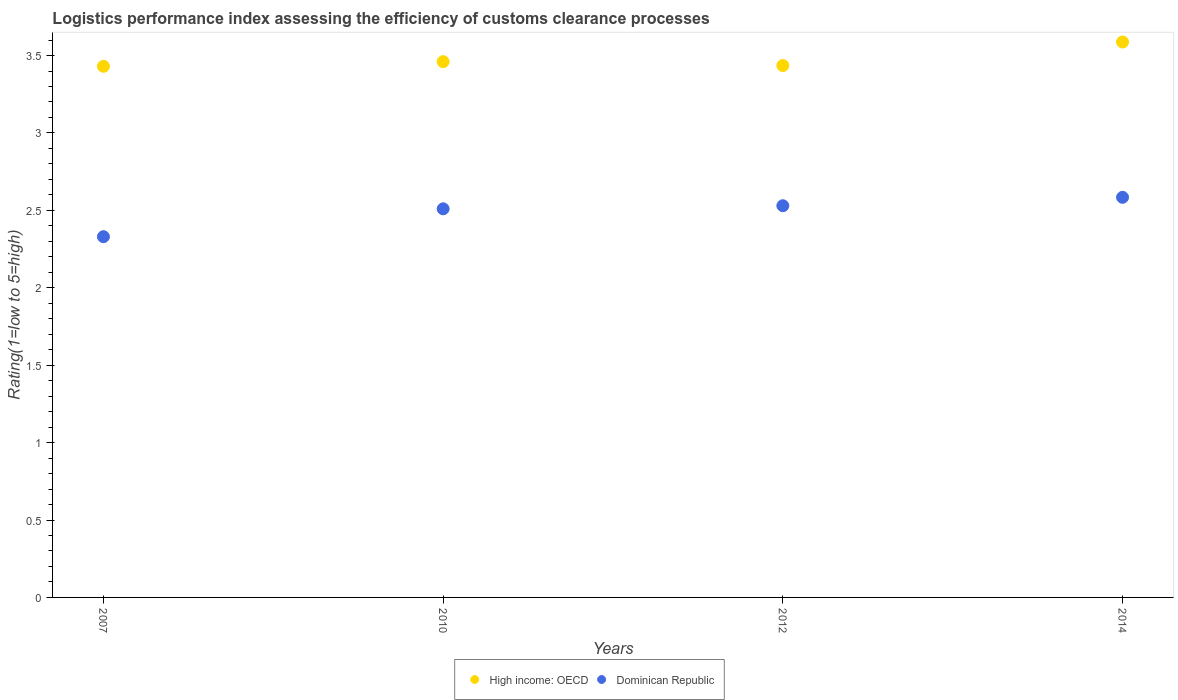How many different coloured dotlines are there?
Ensure brevity in your answer.  2. What is the Logistic performance index in High income: OECD in 2010?
Your answer should be compact. 3.46. Across all years, what is the maximum Logistic performance index in Dominican Republic?
Keep it short and to the point. 2.58. Across all years, what is the minimum Logistic performance index in Dominican Republic?
Ensure brevity in your answer.  2.33. In which year was the Logistic performance index in Dominican Republic maximum?
Offer a very short reply. 2014. In which year was the Logistic performance index in Dominican Republic minimum?
Make the answer very short. 2007. What is the total Logistic performance index in Dominican Republic in the graph?
Give a very brief answer. 9.95. What is the difference between the Logistic performance index in Dominican Republic in 2010 and that in 2012?
Keep it short and to the point. -0.02. What is the difference between the Logistic performance index in Dominican Republic in 2014 and the Logistic performance index in High income: OECD in 2007?
Give a very brief answer. -0.85. What is the average Logistic performance index in Dominican Republic per year?
Keep it short and to the point. 2.49. In the year 2007, what is the difference between the Logistic performance index in High income: OECD and Logistic performance index in Dominican Republic?
Ensure brevity in your answer.  1.1. What is the ratio of the Logistic performance index in High income: OECD in 2010 to that in 2012?
Keep it short and to the point. 1.01. Is the Logistic performance index in Dominican Republic in 2007 less than that in 2014?
Ensure brevity in your answer.  Yes. Is the difference between the Logistic performance index in High income: OECD in 2010 and 2012 greater than the difference between the Logistic performance index in Dominican Republic in 2010 and 2012?
Provide a short and direct response. Yes. What is the difference between the highest and the second highest Logistic performance index in Dominican Republic?
Ensure brevity in your answer.  0.05. What is the difference between the highest and the lowest Logistic performance index in High income: OECD?
Provide a succinct answer. 0.16. Does the Logistic performance index in High income: OECD monotonically increase over the years?
Offer a very short reply. No. Is the Logistic performance index in High income: OECD strictly greater than the Logistic performance index in Dominican Republic over the years?
Give a very brief answer. Yes. Is the Logistic performance index in High income: OECD strictly less than the Logistic performance index in Dominican Republic over the years?
Make the answer very short. No. How many dotlines are there?
Make the answer very short. 2. What is the difference between two consecutive major ticks on the Y-axis?
Offer a terse response. 0.5. Are the values on the major ticks of Y-axis written in scientific E-notation?
Keep it short and to the point. No. Does the graph contain any zero values?
Your answer should be very brief. No. Does the graph contain grids?
Keep it short and to the point. No. How many legend labels are there?
Your response must be concise. 2. How are the legend labels stacked?
Offer a terse response. Horizontal. What is the title of the graph?
Ensure brevity in your answer.  Logistics performance index assessing the efficiency of customs clearance processes. Does "Lesotho" appear as one of the legend labels in the graph?
Your answer should be very brief. No. What is the label or title of the X-axis?
Your answer should be very brief. Years. What is the label or title of the Y-axis?
Provide a short and direct response. Rating(1=low to 5=high). What is the Rating(1=low to 5=high) in High income: OECD in 2007?
Offer a terse response. 3.43. What is the Rating(1=low to 5=high) of Dominican Republic in 2007?
Offer a very short reply. 2.33. What is the Rating(1=low to 5=high) of High income: OECD in 2010?
Make the answer very short. 3.46. What is the Rating(1=low to 5=high) in Dominican Republic in 2010?
Ensure brevity in your answer.  2.51. What is the Rating(1=low to 5=high) in High income: OECD in 2012?
Provide a short and direct response. 3.44. What is the Rating(1=low to 5=high) in Dominican Republic in 2012?
Offer a terse response. 2.53. What is the Rating(1=low to 5=high) of High income: OECD in 2014?
Your answer should be very brief. 3.59. What is the Rating(1=low to 5=high) of Dominican Republic in 2014?
Your answer should be very brief. 2.58. Across all years, what is the maximum Rating(1=low to 5=high) in High income: OECD?
Offer a terse response. 3.59. Across all years, what is the maximum Rating(1=low to 5=high) in Dominican Republic?
Give a very brief answer. 2.58. Across all years, what is the minimum Rating(1=low to 5=high) of High income: OECD?
Provide a succinct answer. 3.43. Across all years, what is the minimum Rating(1=low to 5=high) in Dominican Republic?
Your response must be concise. 2.33. What is the total Rating(1=low to 5=high) of High income: OECD in the graph?
Make the answer very short. 13.91. What is the total Rating(1=low to 5=high) of Dominican Republic in the graph?
Your response must be concise. 9.95. What is the difference between the Rating(1=low to 5=high) in High income: OECD in 2007 and that in 2010?
Provide a succinct answer. -0.03. What is the difference between the Rating(1=low to 5=high) of Dominican Republic in 2007 and that in 2010?
Give a very brief answer. -0.18. What is the difference between the Rating(1=low to 5=high) of High income: OECD in 2007 and that in 2012?
Give a very brief answer. -0. What is the difference between the Rating(1=low to 5=high) in High income: OECD in 2007 and that in 2014?
Offer a very short reply. -0.16. What is the difference between the Rating(1=low to 5=high) of Dominican Republic in 2007 and that in 2014?
Offer a very short reply. -0.25. What is the difference between the Rating(1=low to 5=high) in High income: OECD in 2010 and that in 2012?
Your answer should be very brief. 0.03. What is the difference between the Rating(1=low to 5=high) of Dominican Republic in 2010 and that in 2012?
Offer a very short reply. -0.02. What is the difference between the Rating(1=low to 5=high) of High income: OECD in 2010 and that in 2014?
Provide a short and direct response. -0.13. What is the difference between the Rating(1=low to 5=high) in Dominican Republic in 2010 and that in 2014?
Make the answer very short. -0.07. What is the difference between the Rating(1=low to 5=high) in High income: OECD in 2012 and that in 2014?
Your answer should be compact. -0.15. What is the difference between the Rating(1=low to 5=high) in Dominican Republic in 2012 and that in 2014?
Provide a succinct answer. -0.05. What is the difference between the Rating(1=low to 5=high) in High income: OECD in 2007 and the Rating(1=low to 5=high) in Dominican Republic in 2010?
Provide a succinct answer. 0.92. What is the difference between the Rating(1=low to 5=high) of High income: OECD in 2007 and the Rating(1=low to 5=high) of Dominican Republic in 2012?
Your answer should be compact. 0.9. What is the difference between the Rating(1=low to 5=high) in High income: OECD in 2007 and the Rating(1=low to 5=high) in Dominican Republic in 2014?
Give a very brief answer. 0.85. What is the difference between the Rating(1=low to 5=high) in High income: OECD in 2010 and the Rating(1=low to 5=high) in Dominican Republic in 2012?
Your response must be concise. 0.93. What is the difference between the Rating(1=low to 5=high) of High income: OECD in 2010 and the Rating(1=low to 5=high) of Dominican Republic in 2014?
Make the answer very short. 0.88. What is the difference between the Rating(1=low to 5=high) of High income: OECD in 2012 and the Rating(1=low to 5=high) of Dominican Republic in 2014?
Give a very brief answer. 0.85. What is the average Rating(1=low to 5=high) in High income: OECD per year?
Keep it short and to the point. 3.48. What is the average Rating(1=low to 5=high) of Dominican Republic per year?
Ensure brevity in your answer.  2.49. In the year 2007, what is the difference between the Rating(1=low to 5=high) of High income: OECD and Rating(1=low to 5=high) of Dominican Republic?
Give a very brief answer. 1.1. In the year 2010, what is the difference between the Rating(1=low to 5=high) of High income: OECD and Rating(1=low to 5=high) of Dominican Republic?
Ensure brevity in your answer.  0.95. In the year 2012, what is the difference between the Rating(1=low to 5=high) of High income: OECD and Rating(1=low to 5=high) of Dominican Republic?
Offer a very short reply. 0.91. What is the ratio of the Rating(1=low to 5=high) of Dominican Republic in 2007 to that in 2010?
Offer a terse response. 0.93. What is the ratio of the Rating(1=low to 5=high) in Dominican Republic in 2007 to that in 2012?
Your answer should be compact. 0.92. What is the ratio of the Rating(1=low to 5=high) in High income: OECD in 2007 to that in 2014?
Provide a succinct answer. 0.96. What is the ratio of the Rating(1=low to 5=high) of Dominican Republic in 2007 to that in 2014?
Keep it short and to the point. 0.9. What is the ratio of the Rating(1=low to 5=high) in High income: OECD in 2010 to that in 2012?
Keep it short and to the point. 1.01. What is the ratio of the Rating(1=low to 5=high) in High income: OECD in 2010 to that in 2014?
Your answer should be compact. 0.96. What is the ratio of the Rating(1=low to 5=high) of Dominican Republic in 2010 to that in 2014?
Make the answer very short. 0.97. What is the ratio of the Rating(1=low to 5=high) in High income: OECD in 2012 to that in 2014?
Make the answer very short. 0.96. What is the ratio of the Rating(1=low to 5=high) in Dominican Republic in 2012 to that in 2014?
Provide a short and direct response. 0.98. What is the difference between the highest and the second highest Rating(1=low to 5=high) in High income: OECD?
Your response must be concise. 0.13. What is the difference between the highest and the second highest Rating(1=low to 5=high) in Dominican Republic?
Make the answer very short. 0.05. What is the difference between the highest and the lowest Rating(1=low to 5=high) in High income: OECD?
Ensure brevity in your answer.  0.16. What is the difference between the highest and the lowest Rating(1=low to 5=high) in Dominican Republic?
Offer a terse response. 0.25. 